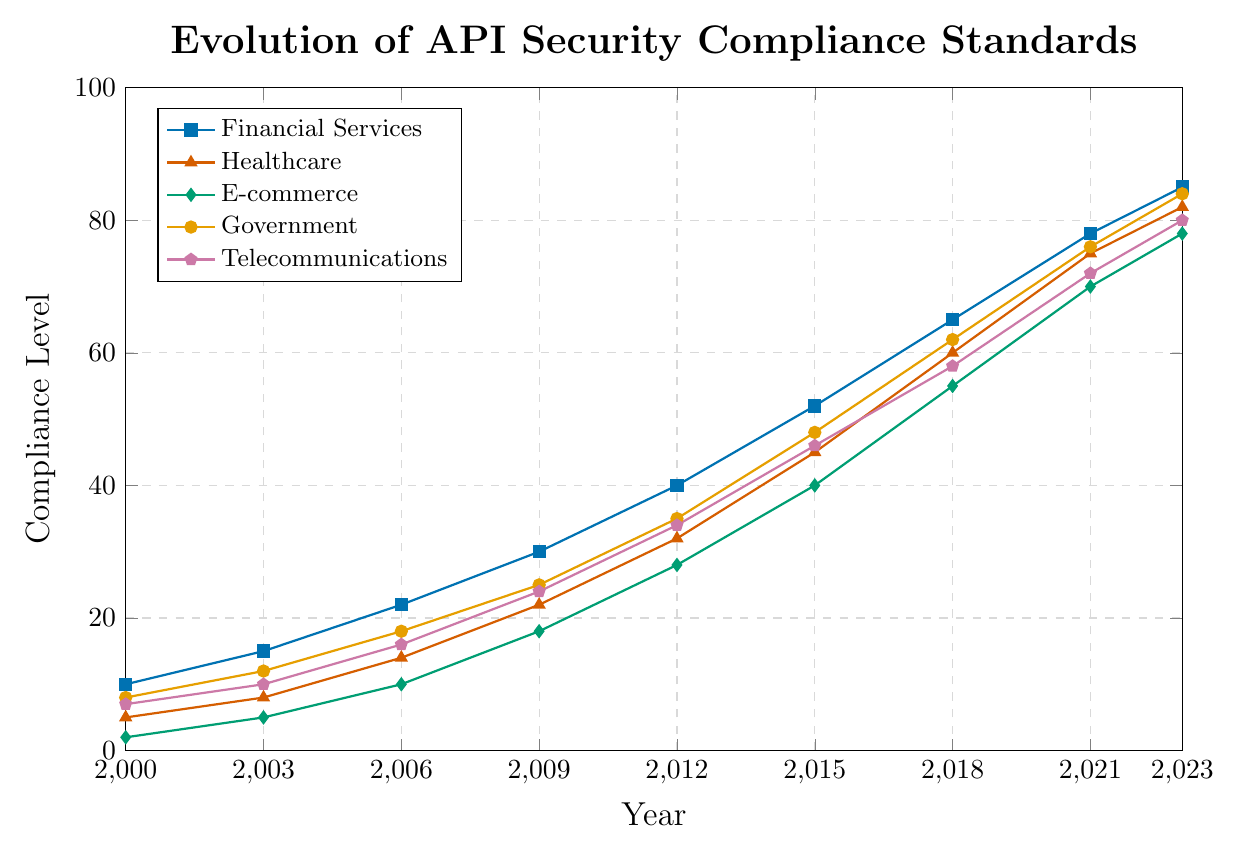What year did Financial Services have a compliance level of 78? According to the chart, the compliance level of Financial Services reached 78 in the year 2021. This can be observed directly from the plotted data points.
Answer: 2021 Which industry had the highest compliance level in 2023? By examining the plotted data points in the year 2023, it is noticeable that Government had the highest compliance level of 84, followed by Financial Services.
Answer: Government What is the average compliance level for Healthcare from 2015 to 2023? To find the average compliance level, sum the values for Healthcare from 2015 (45), 2018 (60), 2021 (75), and 2023 (82), then divide by the number of years (4). \( (45 + 60 + 75 + 82) / 4 = 262 / 4 = 65.5 \)
Answer: 65.5 Comparing the compliance levels in 2006, which industry had the lowest compliance level? By comparing the compliance levels of all industries in 2006 from the chart, it's evident that E-commerce had the lowest compliance level at 10.
Answer: E-commerce Which industries showed the largest increase in compliance levels from 2000 to 2023? Calculating the difference for each industry (2023 data minus 2000 data): Financial Services: \(85-10=75\), Healthcare: \(82-5=77\), E-commerce: \(78-2=76\), Government: \(84-8=76\), Telecommunications: \(80-7=73\). Healthcare experienced the largest increase in compliance levels by 77 points, followed by E-commerce and Government both with increases of 76 points.
Answer: Healthcare What year did Government surpass Financial Services in compliance levels? By observing the year-over-year progression of both industries, it is noticeable that Government surpassed Financial Services in compliance levels in the year 2006, where Government's level was 18 while Financial Services was 22, however, in 2012 they both had 35 and 40 respectively, by 2015 Financial Services level reached 52 and Government 48, confirming that in 2006 would be the year Governance surpassed Financial Services
Answer: 2006 